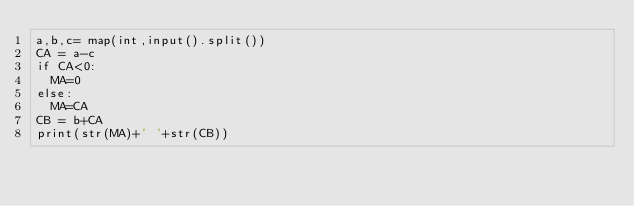Convert code to text. <code><loc_0><loc_0><loc_500><loc_500><_Python_>a,b,c= map(int,input().split())
CA = a-c
if CA<0:
  MA=0
else:
  MA=CA
CB = b+CA
print(str(MA)+' '+str(CB))</code> 